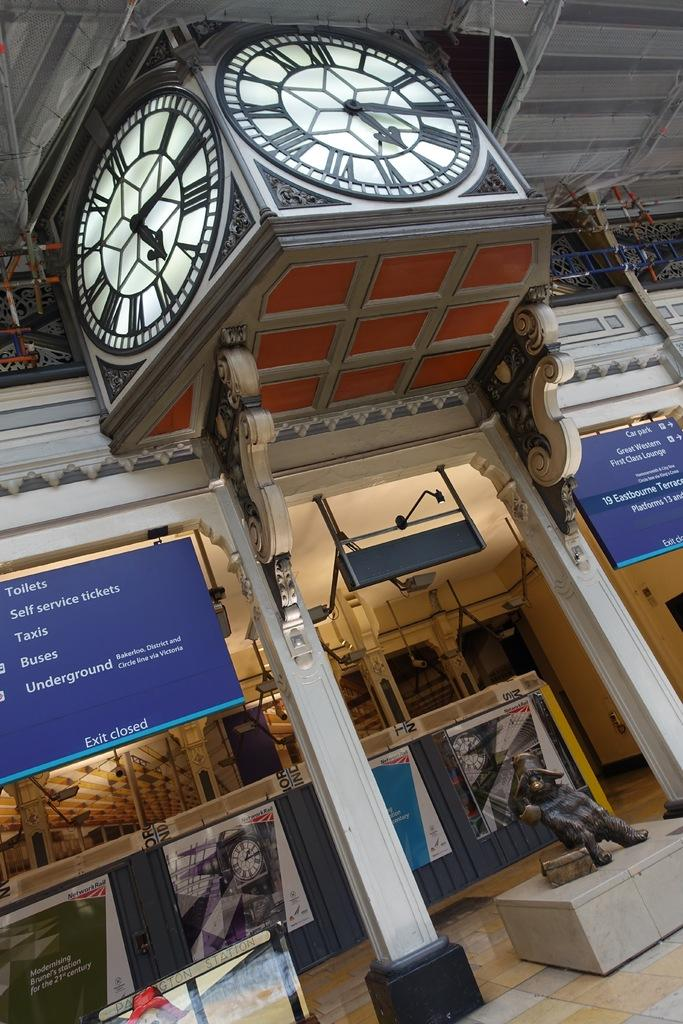What object is located at the top of the picture? There is a clock at the top of the picture. What can be seen on a marble block in the image? There is a sculpture on a marble block in the image. What is displayed on the left side of the picture? There is a screen with text on the left side of the picture. Reasoning: Let's think step by step by step in order to produce the conversation. We start by identifying the main subjects and objects in the image based on the provided facts. We then formulate questions that focus on the location and characteristics of these subjects and objects, ensuring that each question can be answered definitively with the information given. We avoid yes/no questions and ensure that the language is simple and clear. Absurd Question/Answer: What type of property is being sold in the image? There is no indication of any property being sold in the image. Is there a crib visible in the image? No, there is no crib present in the image. Is there a crib visible in the image? No, there is no crib present in the image. 